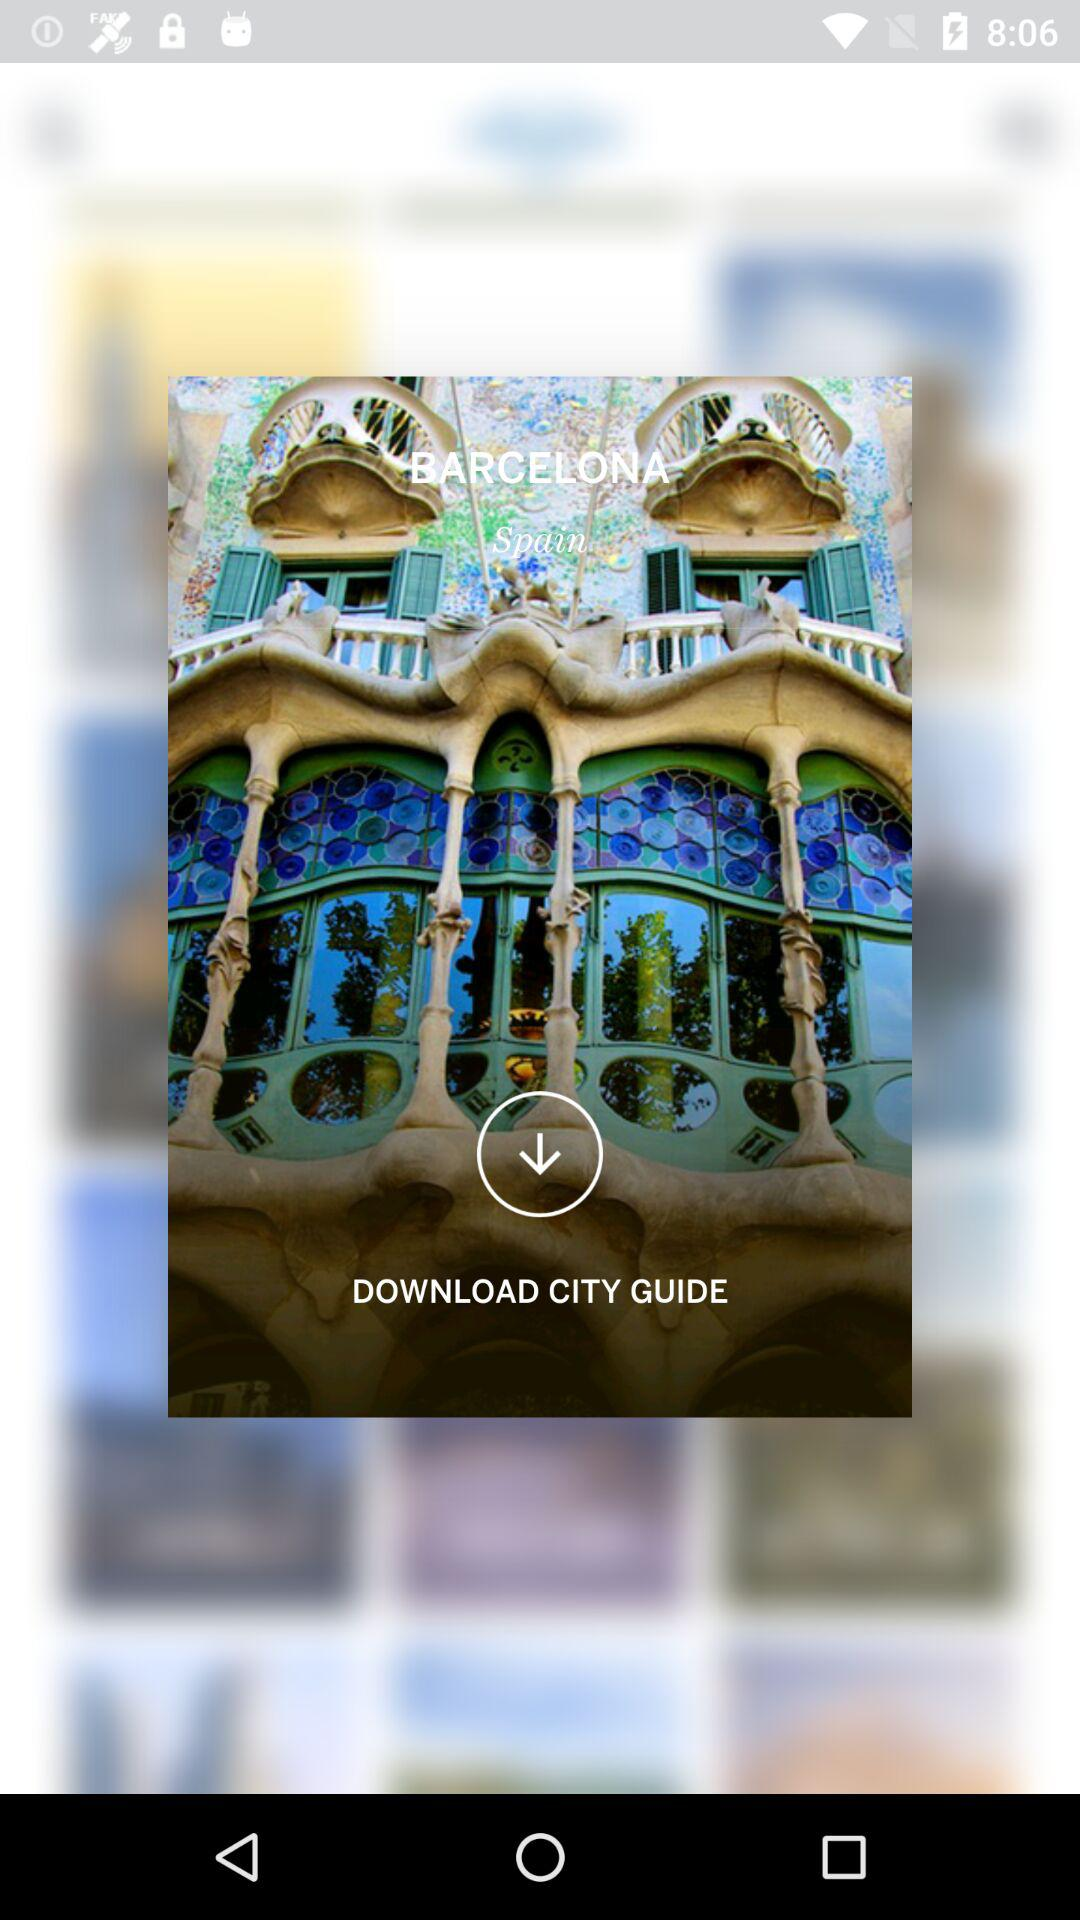What's the city name? The city name is Barcelona. 